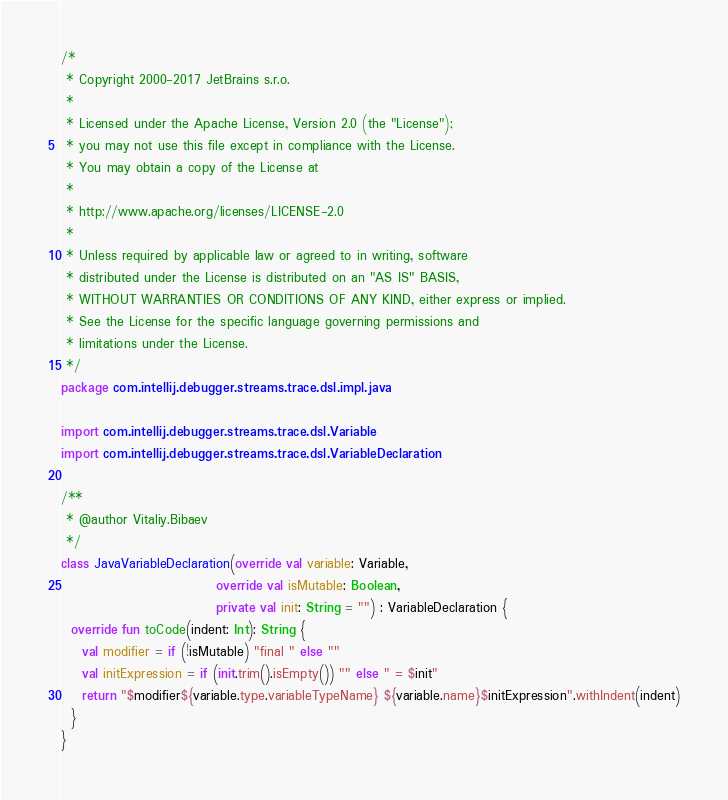Convert code to text. <code><loc_0><loc_0><loc_500><loc_500><_Kotlin_>/*
 * Copyright 2000-2017 JetBrains s.r.o.
 *
 * Licensed under the Apache License, Version 2.0 (the "License");
 * you may not use this file except in compliance with the License.
 * You may obtain a copy of the License at
 *
 * http://www.apache.org/licenses/LICENSE-2.0
 *
 * Unless required by applicable law or agreed to in writing, software
 * distributed under the License is distributed on an "AS IS" BASIS,
 * WITHOUT WARRANTIES OR CONDITIONS OF ANY KIND, either express or implied.
 * See the License for the specific language governing permissions and
 * limitations under the License.
 */
package com.intellij.debugger.streams.trace.dsl.impl.java

import com.intellij.debugger.streams.trace.dsl.Variable
import com.intellij.debugger.streams.trace.dsl.VariableDeclaration

/**
 * @author Vitaliy.Bibaev
 */
class JavaVariableDeclaration(override val variable: Variable,
                              override val isMutable: Boolean,
                              private val init: String = "") : VariableDeclaration {
  override fun toCode(indent: Int): String {
    val modifier = if (!isMutable) "final " else ""
    val initExpression = if (init.trim().isEmpty()) "" else " = $init"
    return "$modifier${variable.type.variableTypeName} ${variable.name}$initExpression".withIndent(indent)
  }
}</code> 